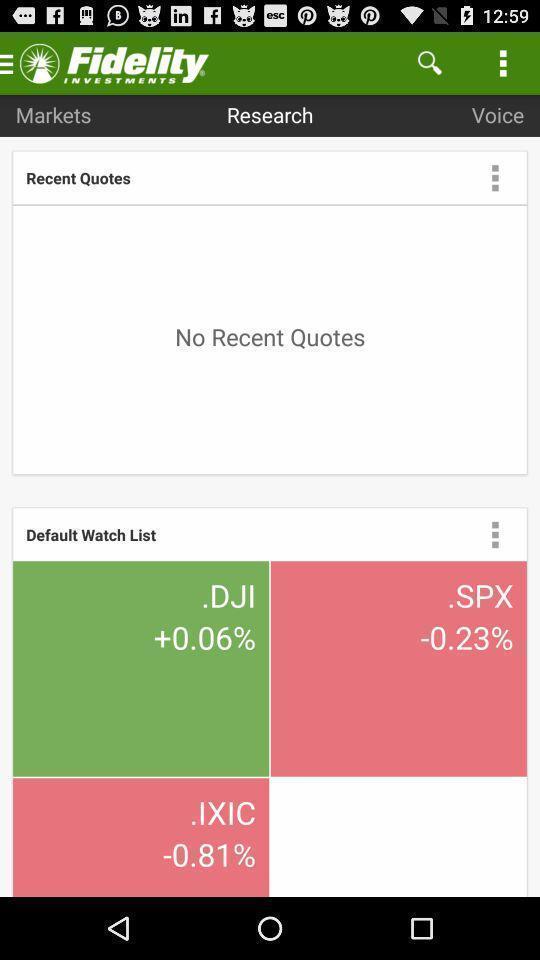Explain what's happening in this screen capture. Welcome to the home page. 